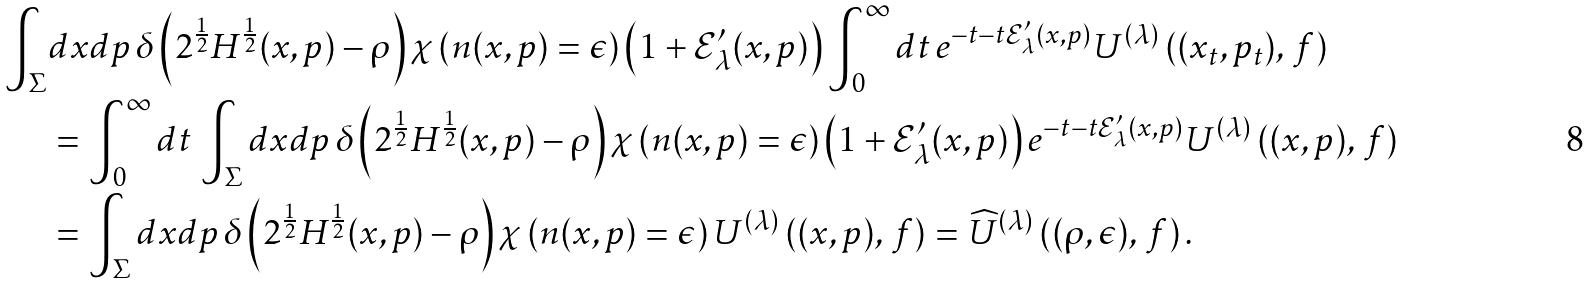<formula> <loc_0><loc_0><loc_500><loc_500>\int _ { \Sigma } & d x d p \, \delta \left ( 2 ^ { \frac { 1 } { 2 } } H ^ { \frac { 1 } { 2 } } ( x , p ) - \rho \right ) \chi \left ( n ( x , p ) = \epsilon \right ) \left ( 1 + \mathcal { E } _ { \lambda } ^ { \prime } ( x , p ) \right ) \int _ { 0 } ^ { \infty } d t \, e ^ { - t - t \mathcal { E } _ { \lambda } ^ { \prime } ( x , p ) } U ^ { ( \lambda ) } \left ( ( x _ { t } , p _ { t } ) , \, f \right ) \\ & = \int _ { 0 } ^ { \infty } d t \, \int _ { \Sigma } d x d p \, \delta \left ( 2 ^ { \frac { 1 } { 2 } } H ^ { \frac { 1 } { 2 } } ( x , p ) - \rho \right ) \chi \left ( n ( x , p ) = \epsilon \right ) \left ( 1 + \mathcal { E } _ { \lambda } ^ { \prime } ( x , p ) \right ) e ^ { - t - t \mathcal { E } _ { \lambda } ^ { \prime } ( x , p ) } U ^ { ( \lambda ) } \left ( ( x , p ) , \, f \right ) \\ & = \int _ { \Sigma } d x d p \, \delta \left ( 2 ^ { \frac { 1 } { 2 } } H ^ { \frac { 1 } { 2 } } ( x , p ) - \rho \right ) \chi \left ( n ( x , p ) = \epsilon \right ) U ^ { ( \lambda ) } \left ( ( x , p ) , \, f \right ) = \widehat { U } ^ { ( \lambda ) } \left ( ( \rho , \epsilon ) , \, f \right ) .</formula> 